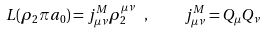Convert formula to latex. <formula><loc_0><loc_0><loc_500><loc_500>L ( \rho _ { 2 } \pi a _ { 0 } ) = j ^ { M } _ { \mu \nu } \rho _ { 2 } ^ { \mu \nu } \ , \quad j ^ { M } _ { \mu \nu } = Q _ { \mu } Q _ { \nu }</formula> 